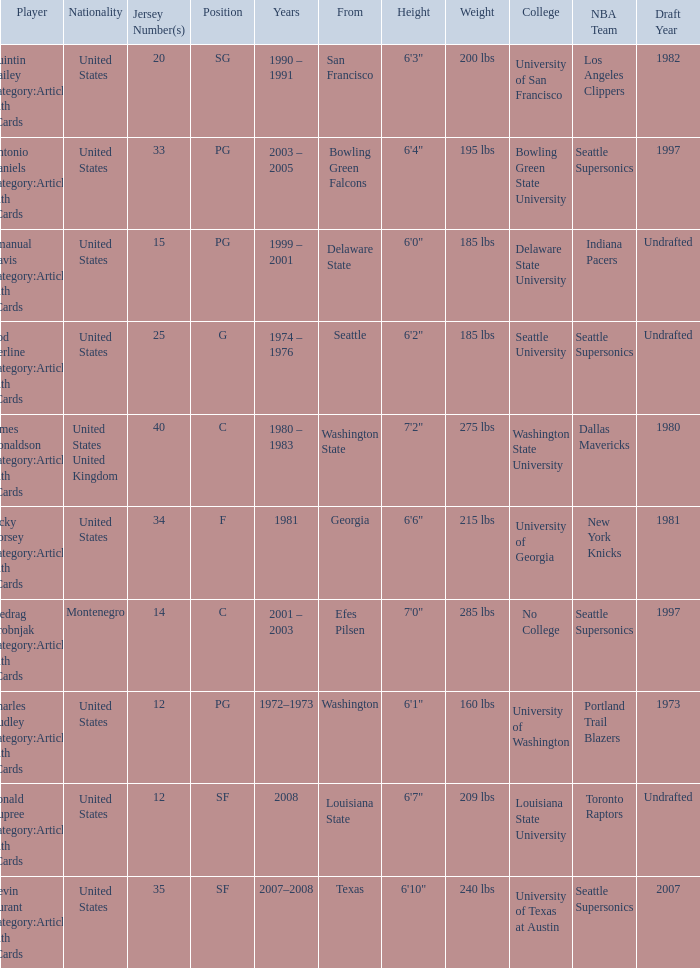What was the nationality of the players with a position of g? United States. 